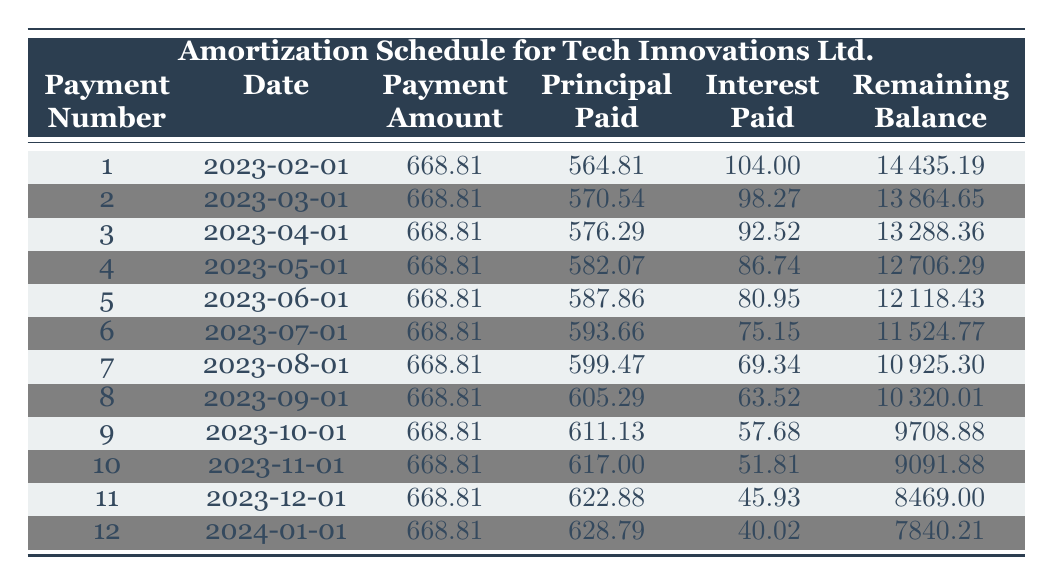What is the total loan amount for Tech Innovations Ltd.? The loan details state that the loan amount is 15000.
Answer: 15000 What is the monthly payment due for Sofia Rodriguez? The loan details indicate the monthly payment is 668.81.
Answer: 668.81 How much was the principal paid in the first payment? The first payment shows that the principal paid is 564.81.
Answer: 564.81 What is the remaining balance after the second payment? The second payment details indicate that the remaining balance after this payment is 13864.65.
Answer: 13864.65 Which payment had the highest interest paid? We look through the interest paid column and find the first payment had 104.00, the second had 98.27, and the trend of decreasing interest paid indicates the first payment is the highest.
Answer: Yes, the first payment has the highest interest paid What is the total interest paid after the first four payments? To find the total interest paid, we sum the interest amounts from the first four payments: 104.00 + 98.27 + 92.52 + 86.74 = 381.53.
Answer: 381.53 Did the principal paid amount increase or decrease from the first payment to the last? The first payment principal is 564.81 and the last payment principal is 628.79, indicating it increased.
Answer: Yes, the principal paid increased What is the average monthly principal payment over the first twelve payments? To find the average, we sum all principal payments (totaling 7132.81) and divide by 12. Thus, 7132.81 / 12 = 594.40 (approx).
Answer: 594.40 How much was the interest paid during the last payment? The last payment shows that the interest paid is 40.02.
Answer: 40.02 